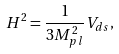Convert formula to latex. <formula><loc_0><loc_0><loc_500><loc_500>H ^ { 2 } = \frac { 1 } { 3 M _ { p l } ^ { 2 } } V _ { d s } ,</formula> 